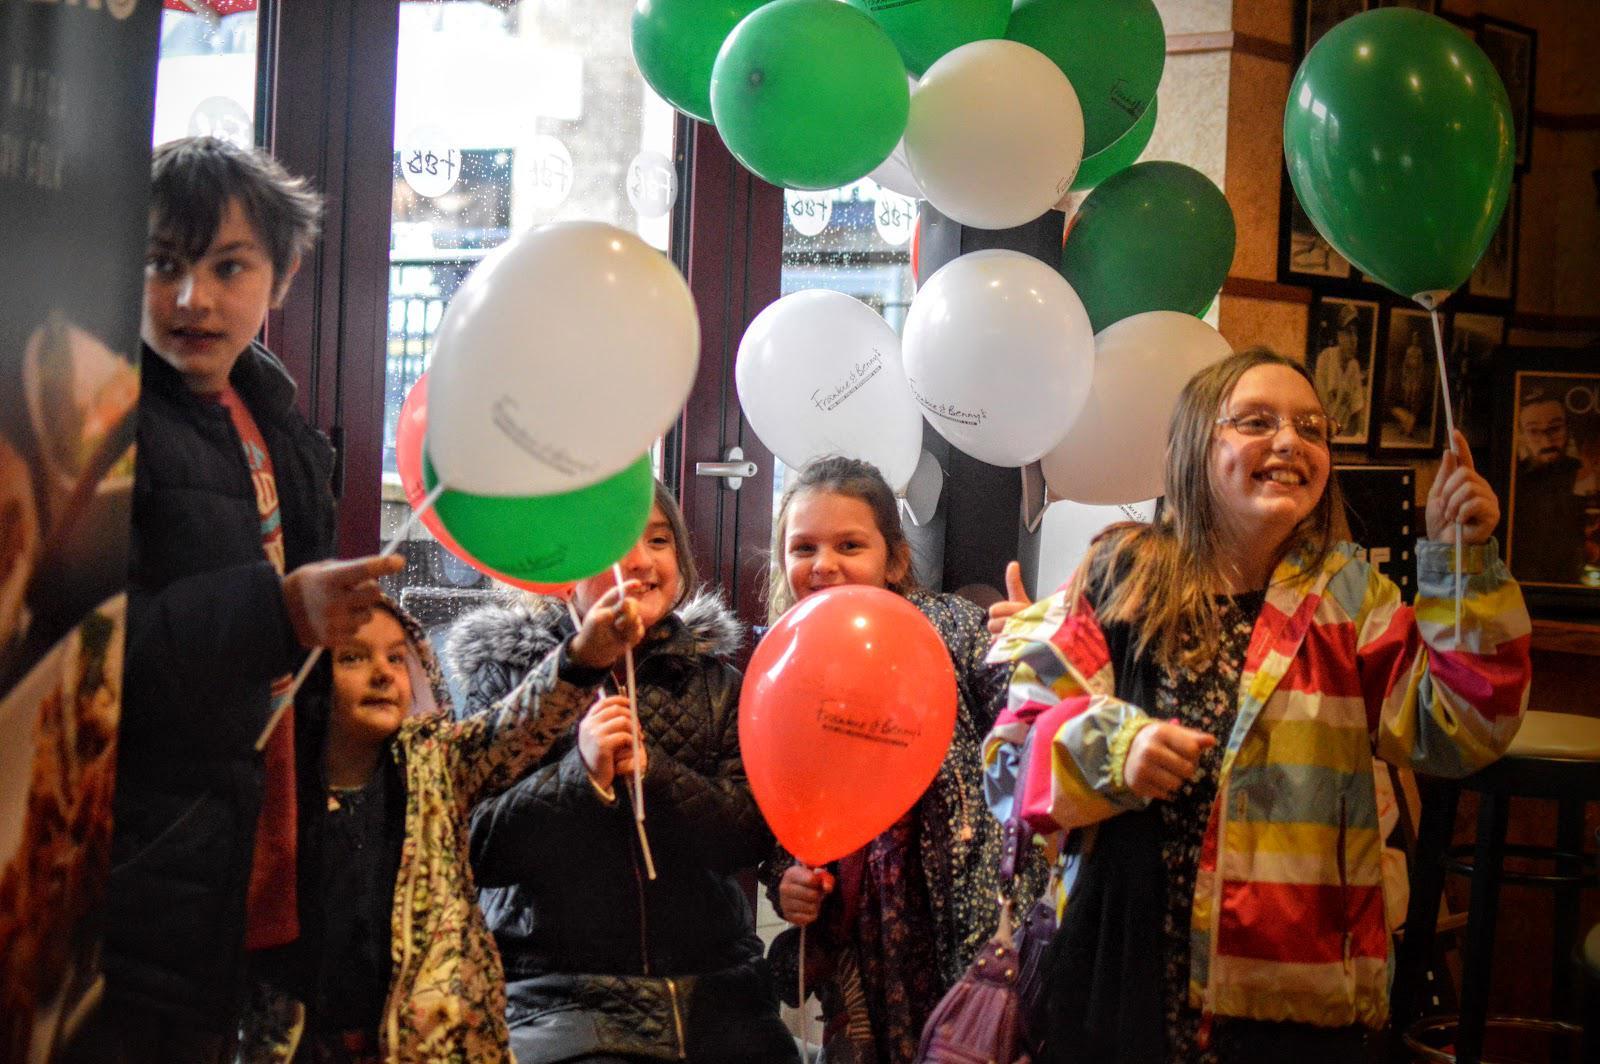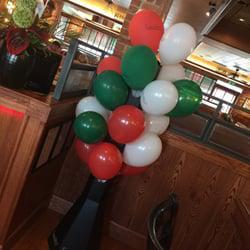The first image is the image on the left, the second image is the image on the right. Given the left and right images, does the statement "The left and right image contains no more than six balloons." hold true? Answer yes or no. No. The first image is the image on the left, the second image is the image on the right. For the images displayed, is the sentence "The left image features no more than four balloons in a restaurant scene, including red and green balloons, and the right image includes a red balloon to the left of a white balloon." factually correct? Answer yes or no. No. 